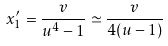Convert formula to latex. <formula><loc_0><loc_0><loc_500><loc_500>x _ { 1 } ^ { \prime } = \frac { v } { u ^ { 4 } - 1 } \simeq \frac { v } { 4 ( u - 1 ) }</formula> 